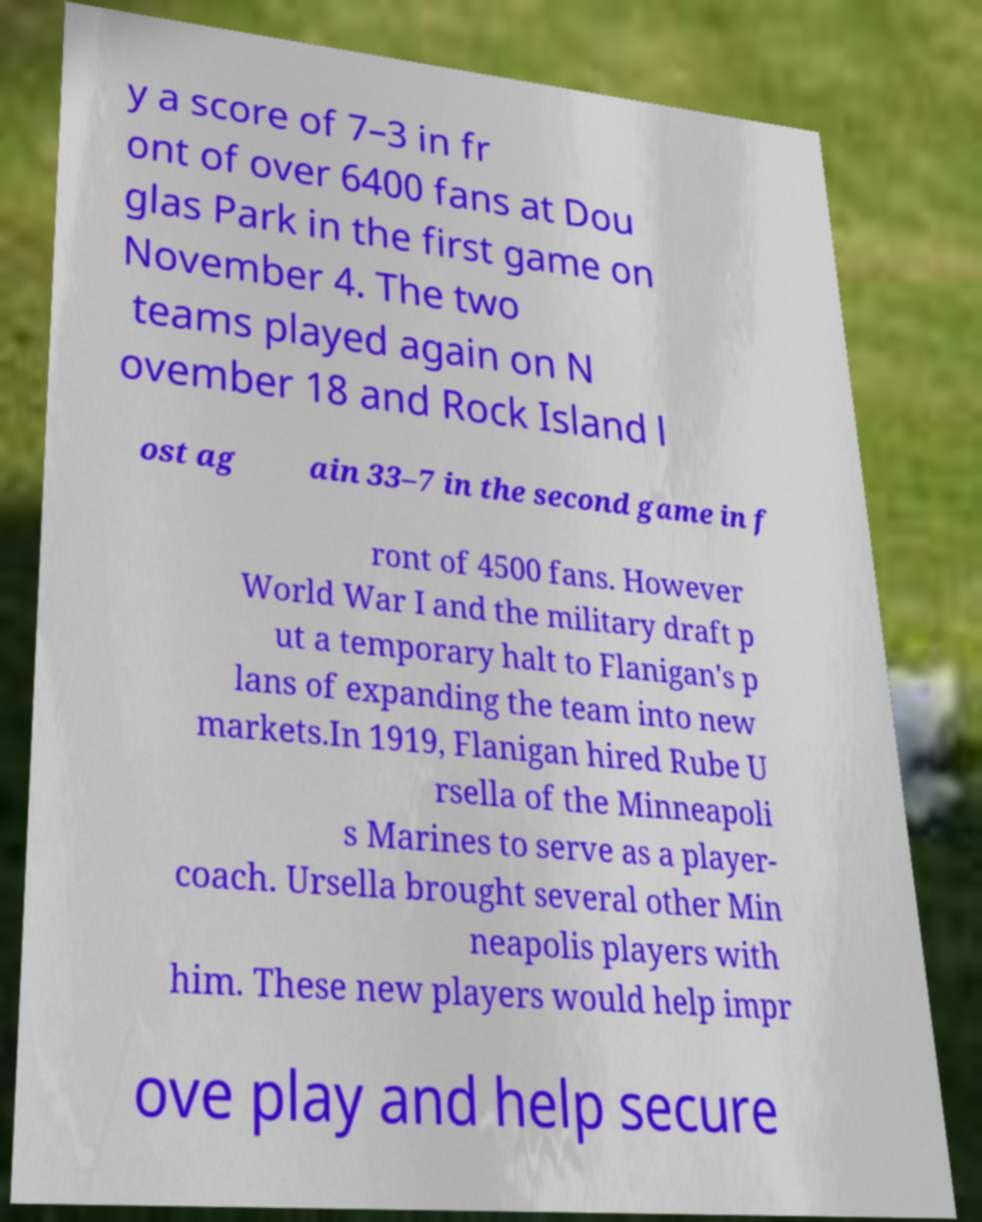I need the written content from this picture converted into text. Can you do that? y a score of 7–3 in fr ont of over 6400 fans at Dou glas Park in the first game on November 4. The two teams played again on N ovember 18 and Rock Island l ost ag ain 33–7 in the second game in f ront of 4500 fans. However World War I and the military draft p ut a temporary halt to Flanigan's p lans of expanding the team into new markets.In 1919, Flanigan hired Rube U rsella of the Minneapoli s Marines to serve as a player- coach. Ursella brought several other Min neapolis players with him. These new players would help impr ove play and help secure 